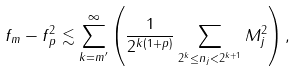Convert formula to latex. <formula><loc_0><loc_0><loc_500><loc_500>\| f _ { m } - f \| _ { p } ^ { 2 } \lesssim \sum _ { k = m ^ { \prime } } ^ { \infty } \left ( \frac { 1 } { 2 ^ { k ( 1 + p ) } } \sum _ { 2 ^ { k } \leq n _ { j } < 2 ^ { k + 1 } } M _ { j } ^ { 2 } \right ) ,</formula> 